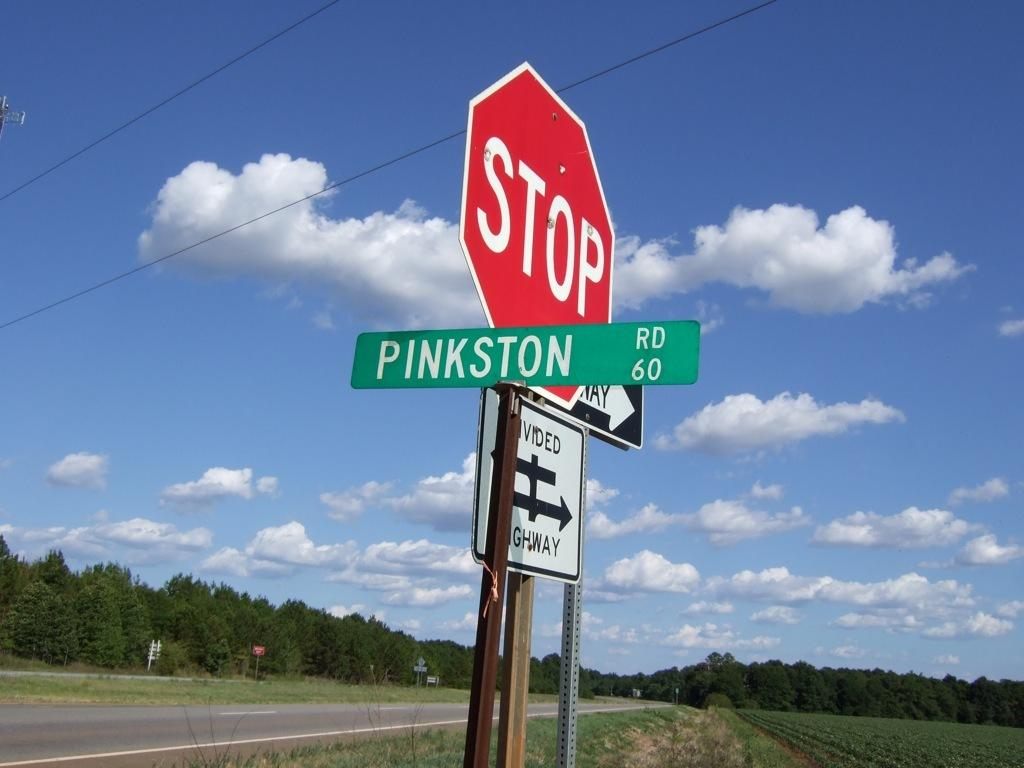<image>
Describe the image concisely. A large red STOP sign stands with other signs such as Pinkston and Divided Highway. 